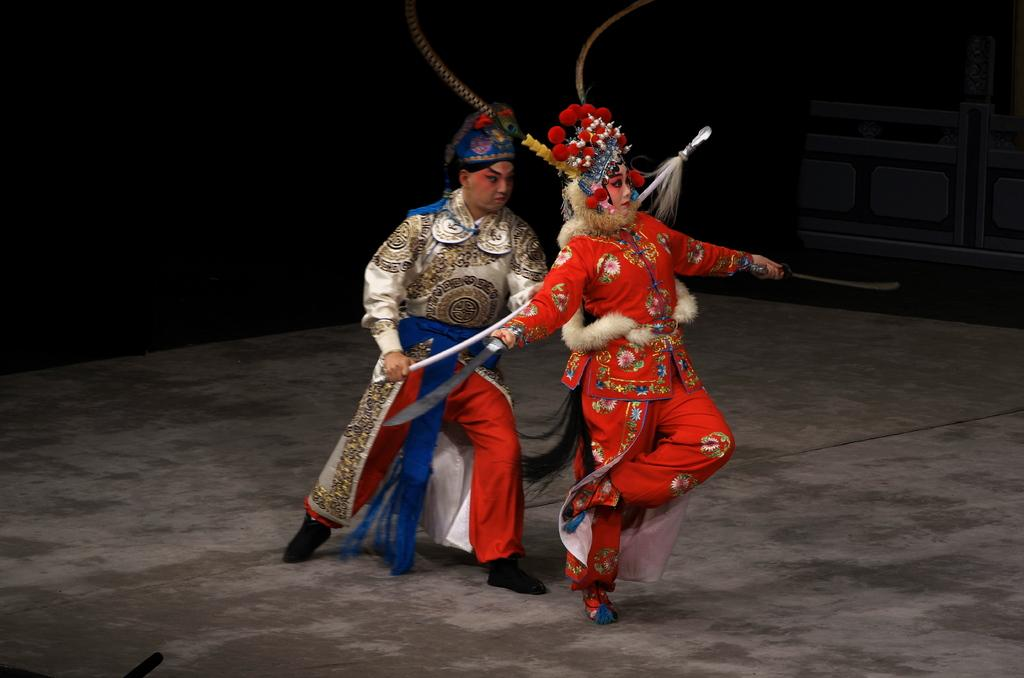How many people are in the image? There are two people in the image. What are the people doing in the image? The people are in motion, wearing costumes, and holding swords. What can be seen in the background of the image? The background of the image is dark, and there is a wall visible. What type of lettuce is being used as a prop in the image? There is no lettuce present in the image. How does the temper of the people in the image affect their performance? The provided facts do not mention anything about the temper of the people in the image, so we cannot determine how it affects their performance. 